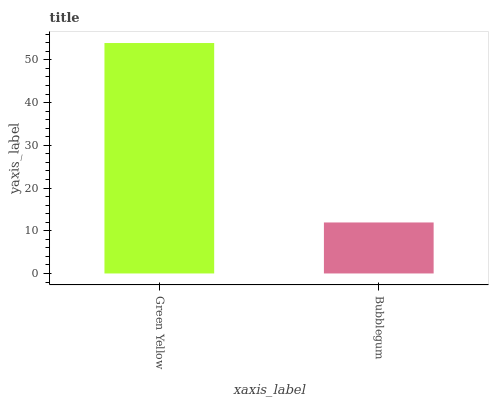Is Bubblegum the minimum?
Answer yes or no. Yes. Is Green Yellow the maximum?
Answer yes or no. Yes. Is Bubblegum the maximum?
Answer yes or no. No. Is Green Yellow greater than Bubblegum?
Answer yes or no. Yes. Is Bubblegum less than Green Yellow?
Answer yes or no. Yes. Is Bubblegum greater than Green Yellow?
Answer yes or no. No. Is Green Yellow less than Bubblegum?
Answer yes or no. No. Is Green Yellow the high median?
Answer yes or no. Yes. Is Bubblegum the low median?
Answer yes or no. Yes. Is Bubblegum the high median?
Answer yes or no. No. Is Green Yellow the low median?
Answer yes or no. No. 